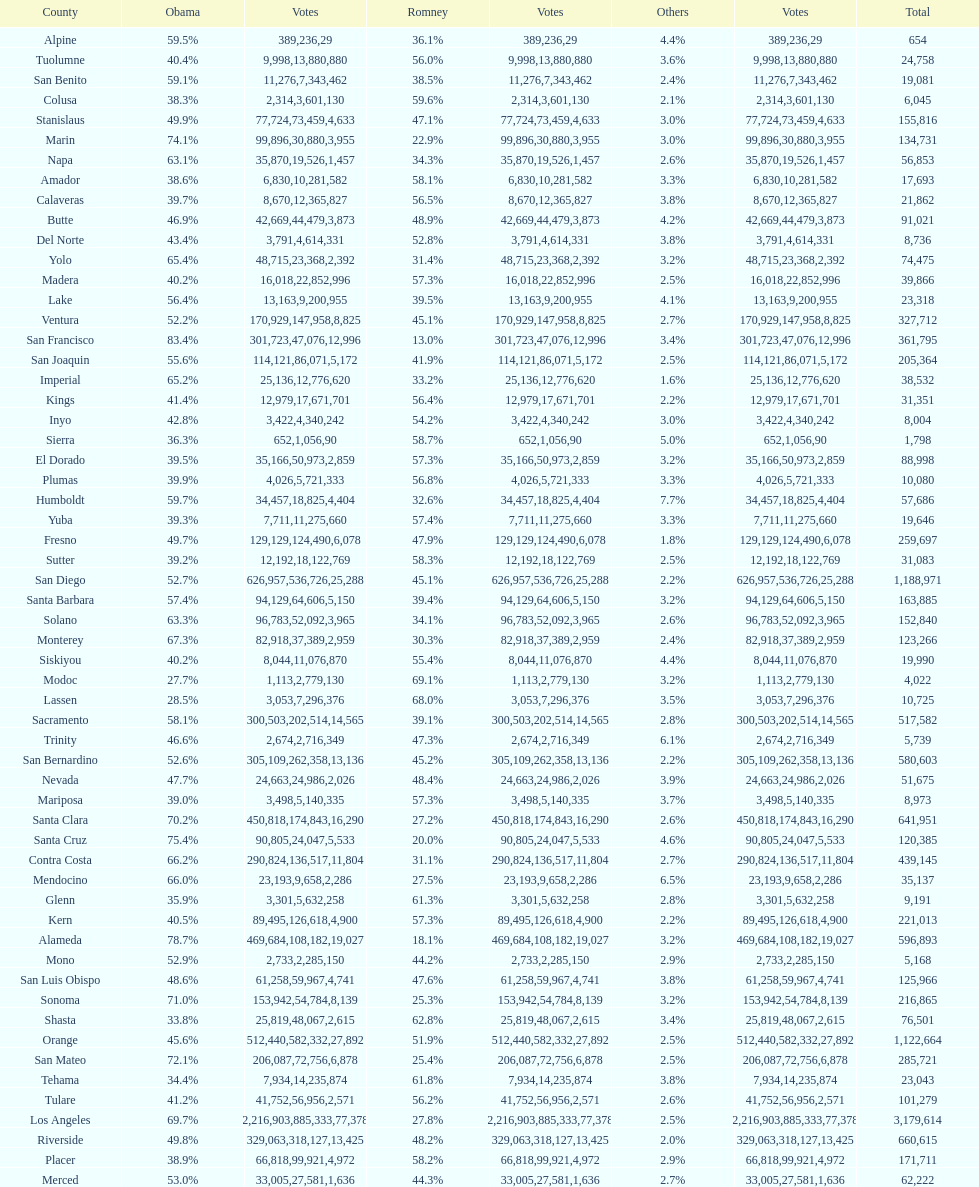Which count had the least number of votes for obama? Modoc. 